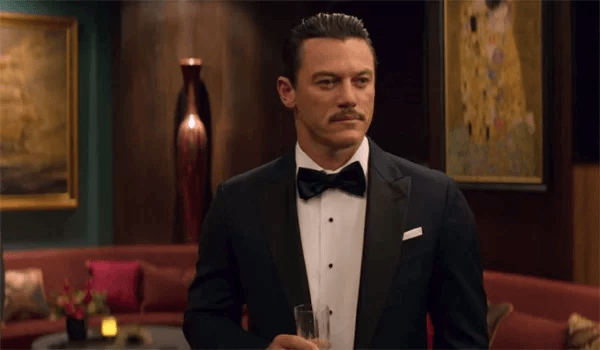How does the attire of the person in the image complement the setting? The black tuxedo and bow tie are classic and timeless choices that match the grandeur and elegance of the room. This attire is appropriate for highly formal occasions, echoing the opulent and sophisticated themes of the setting, and highlights the importance of the event being depicted. 